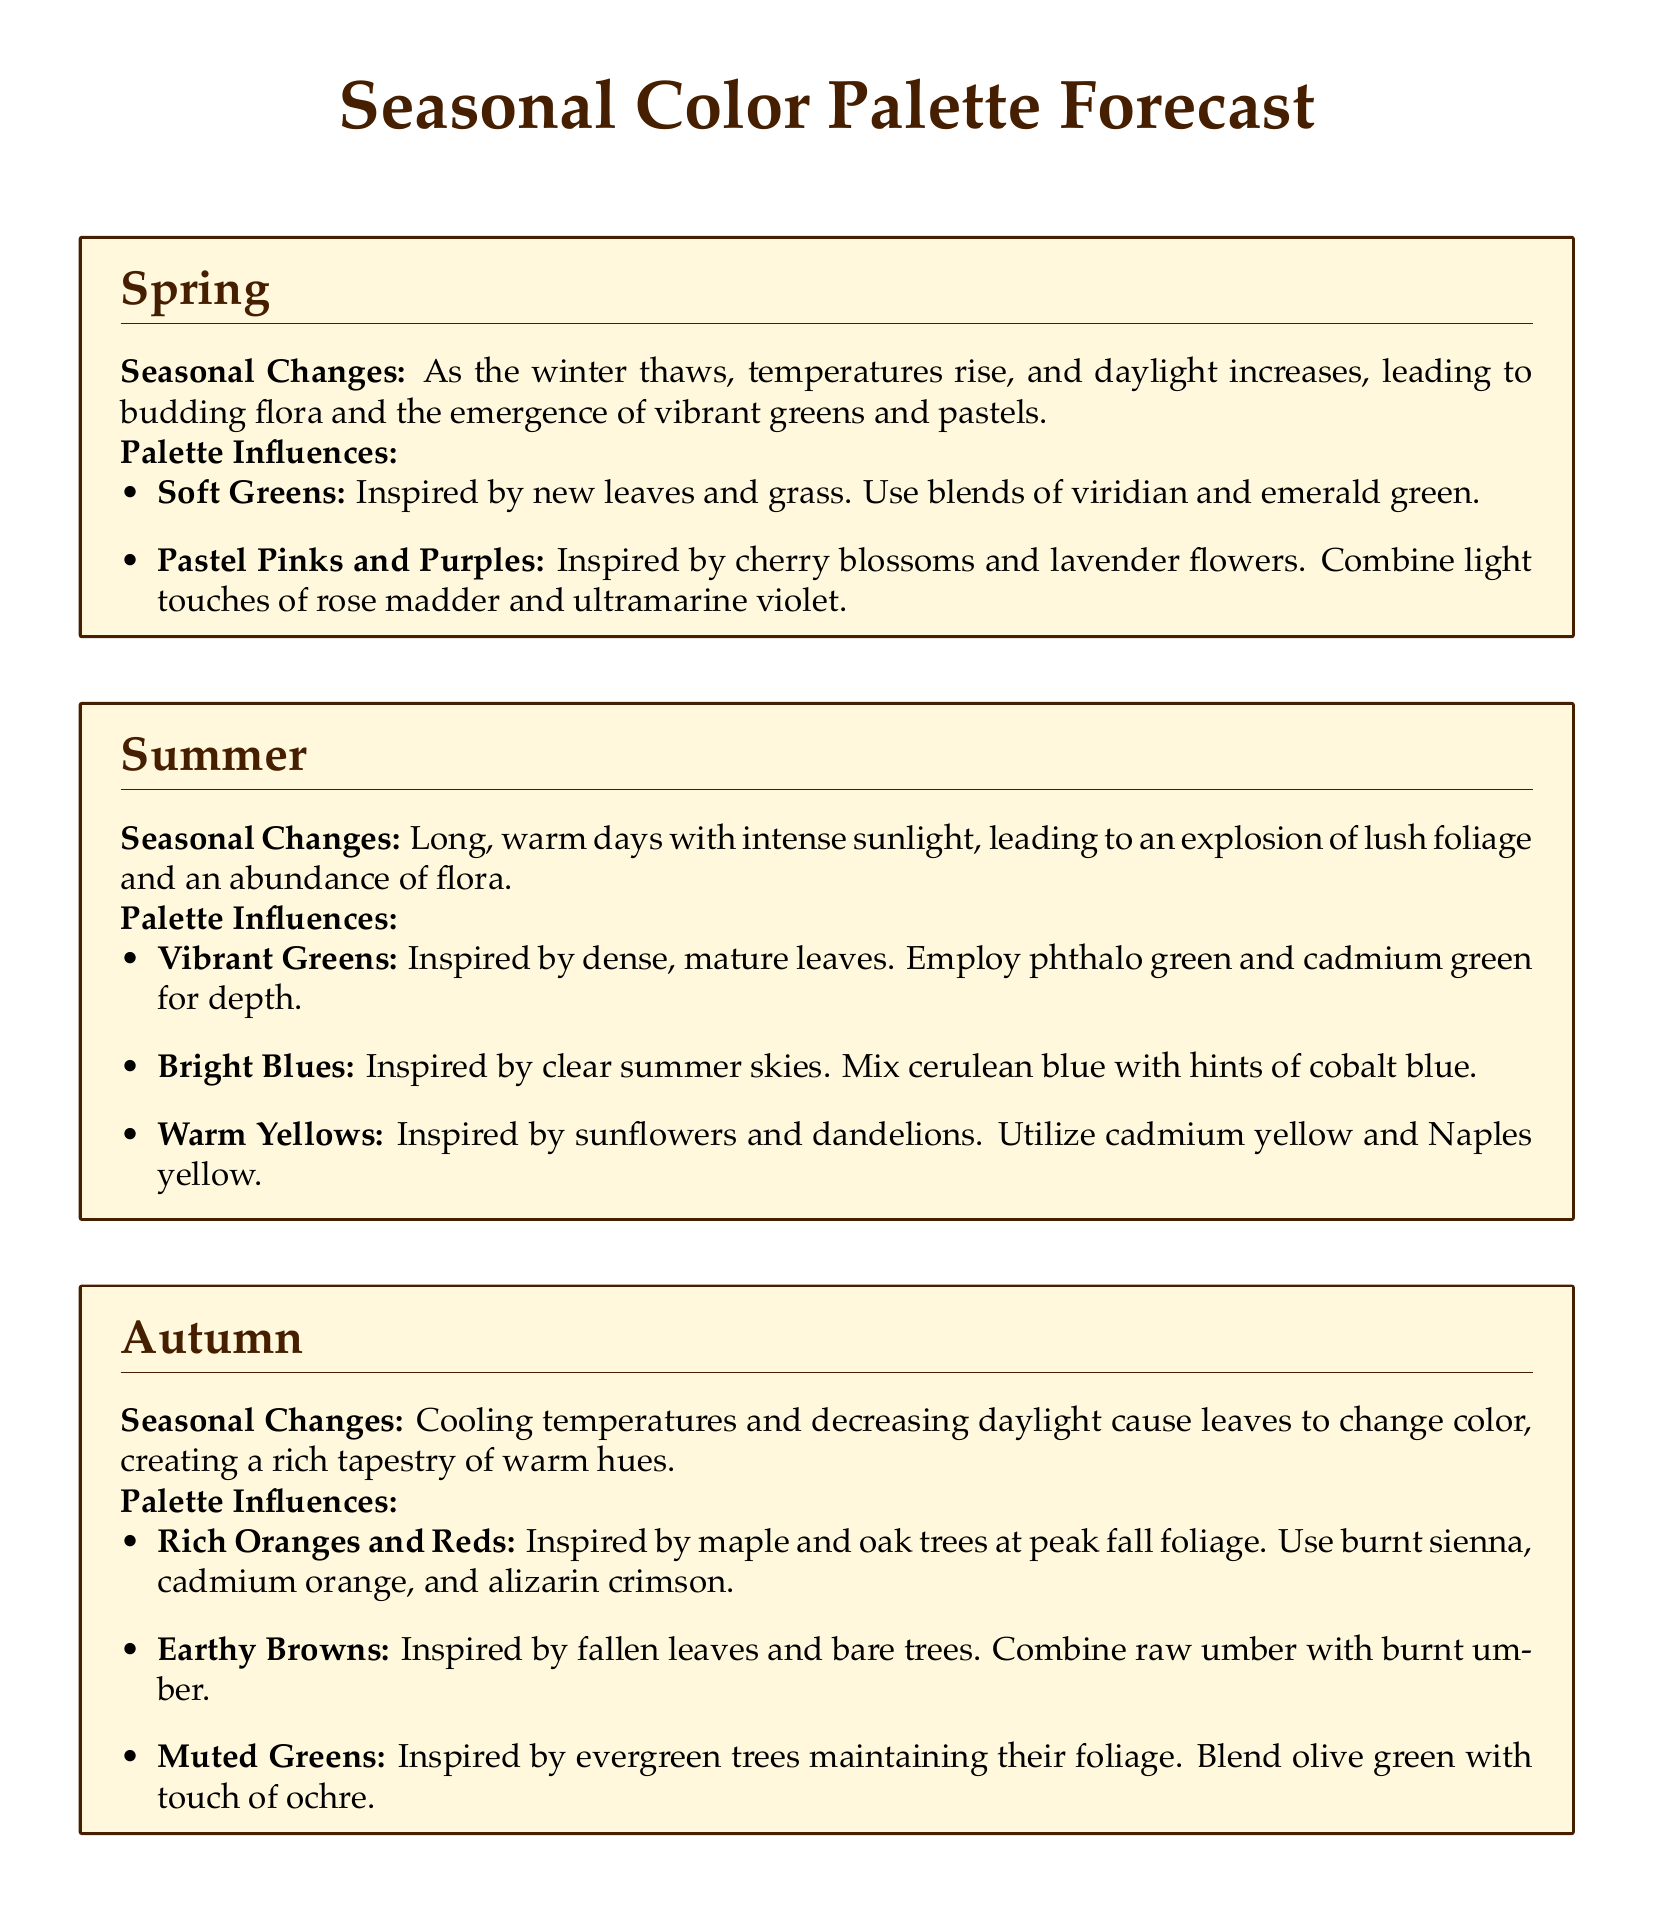What colors inspire the spring palette? The spring palette is inspired by soft greens, pastel pinks, and purples as new flora emerges.
Answer: Soft greens, pastel pinks, and purples Which colors are associated with summer? The summer palette includes vibrant greens, bright blues, and warm yellows as summer blooms flourish.
Answer: Vibrant greens, bright blues, and warm yellows What season features earthy browns in its palette? Earthy browns are included in the autumn palette, influenced by fallen leaves and bare trees.
Answer: Autumn What color is used for snow-covered landscapes in winter? The color for snow-covered landscapes in winter is represented by cool whites and blues.
Answer: Cool whites and blues Which color is prominent in the autumn palette for peak fall foliage? The autumn palette prominently features rich oranges and reds inspired by changing leaves.
Answer: Rich oranges and reds What type of seasonal changes does spring signify? Spring signifies increasing temperatures and budding flora as winter thaws.
Answer: Increasing temperatures and budding flora How does the summer influence color choices in paintings? The summer influences choices with an explosion of lush foliage and clear skies.
Answer: Explosion of lush foliage and clear skies What is the primary influence of the winter season on color selection? The winter season influences color selection with shorter days and snow covering the ground.
Answer: Shorter days and snow covering the ground 